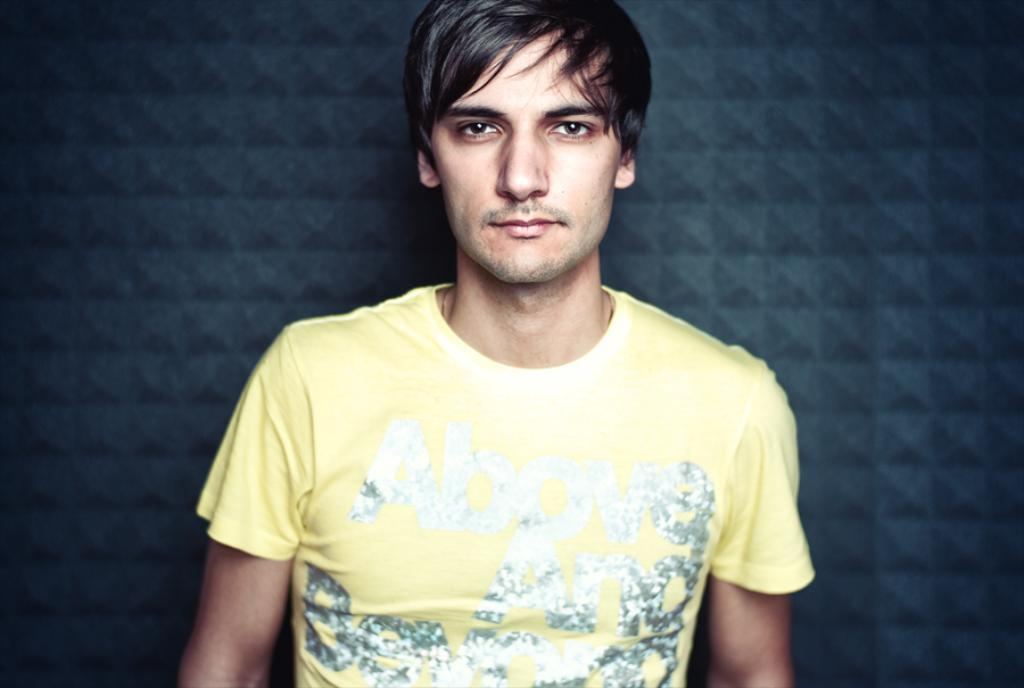What is present in the image? There is a person in the image. What is the person wearing? The person is wearing a yellow t-shirt. What color is the background of the image? The background of the image is blue. What type of silver trousers is the person wearing in the image? There is no mention of trousers, let alone silver trousers, in the image. The person is only described as wearing a yellow t-shirt. How does the person shake hands with someone in the image? There is no indication of a handshake or any other interaction with another person in the image. 